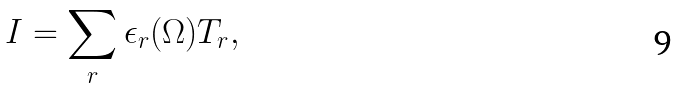<formula> <loc_0><loc_0><loc_500><loc_500>I = \sum _ { r } \epsilon _ { r } ( \Omega ) T _ { r } ,</formula> 